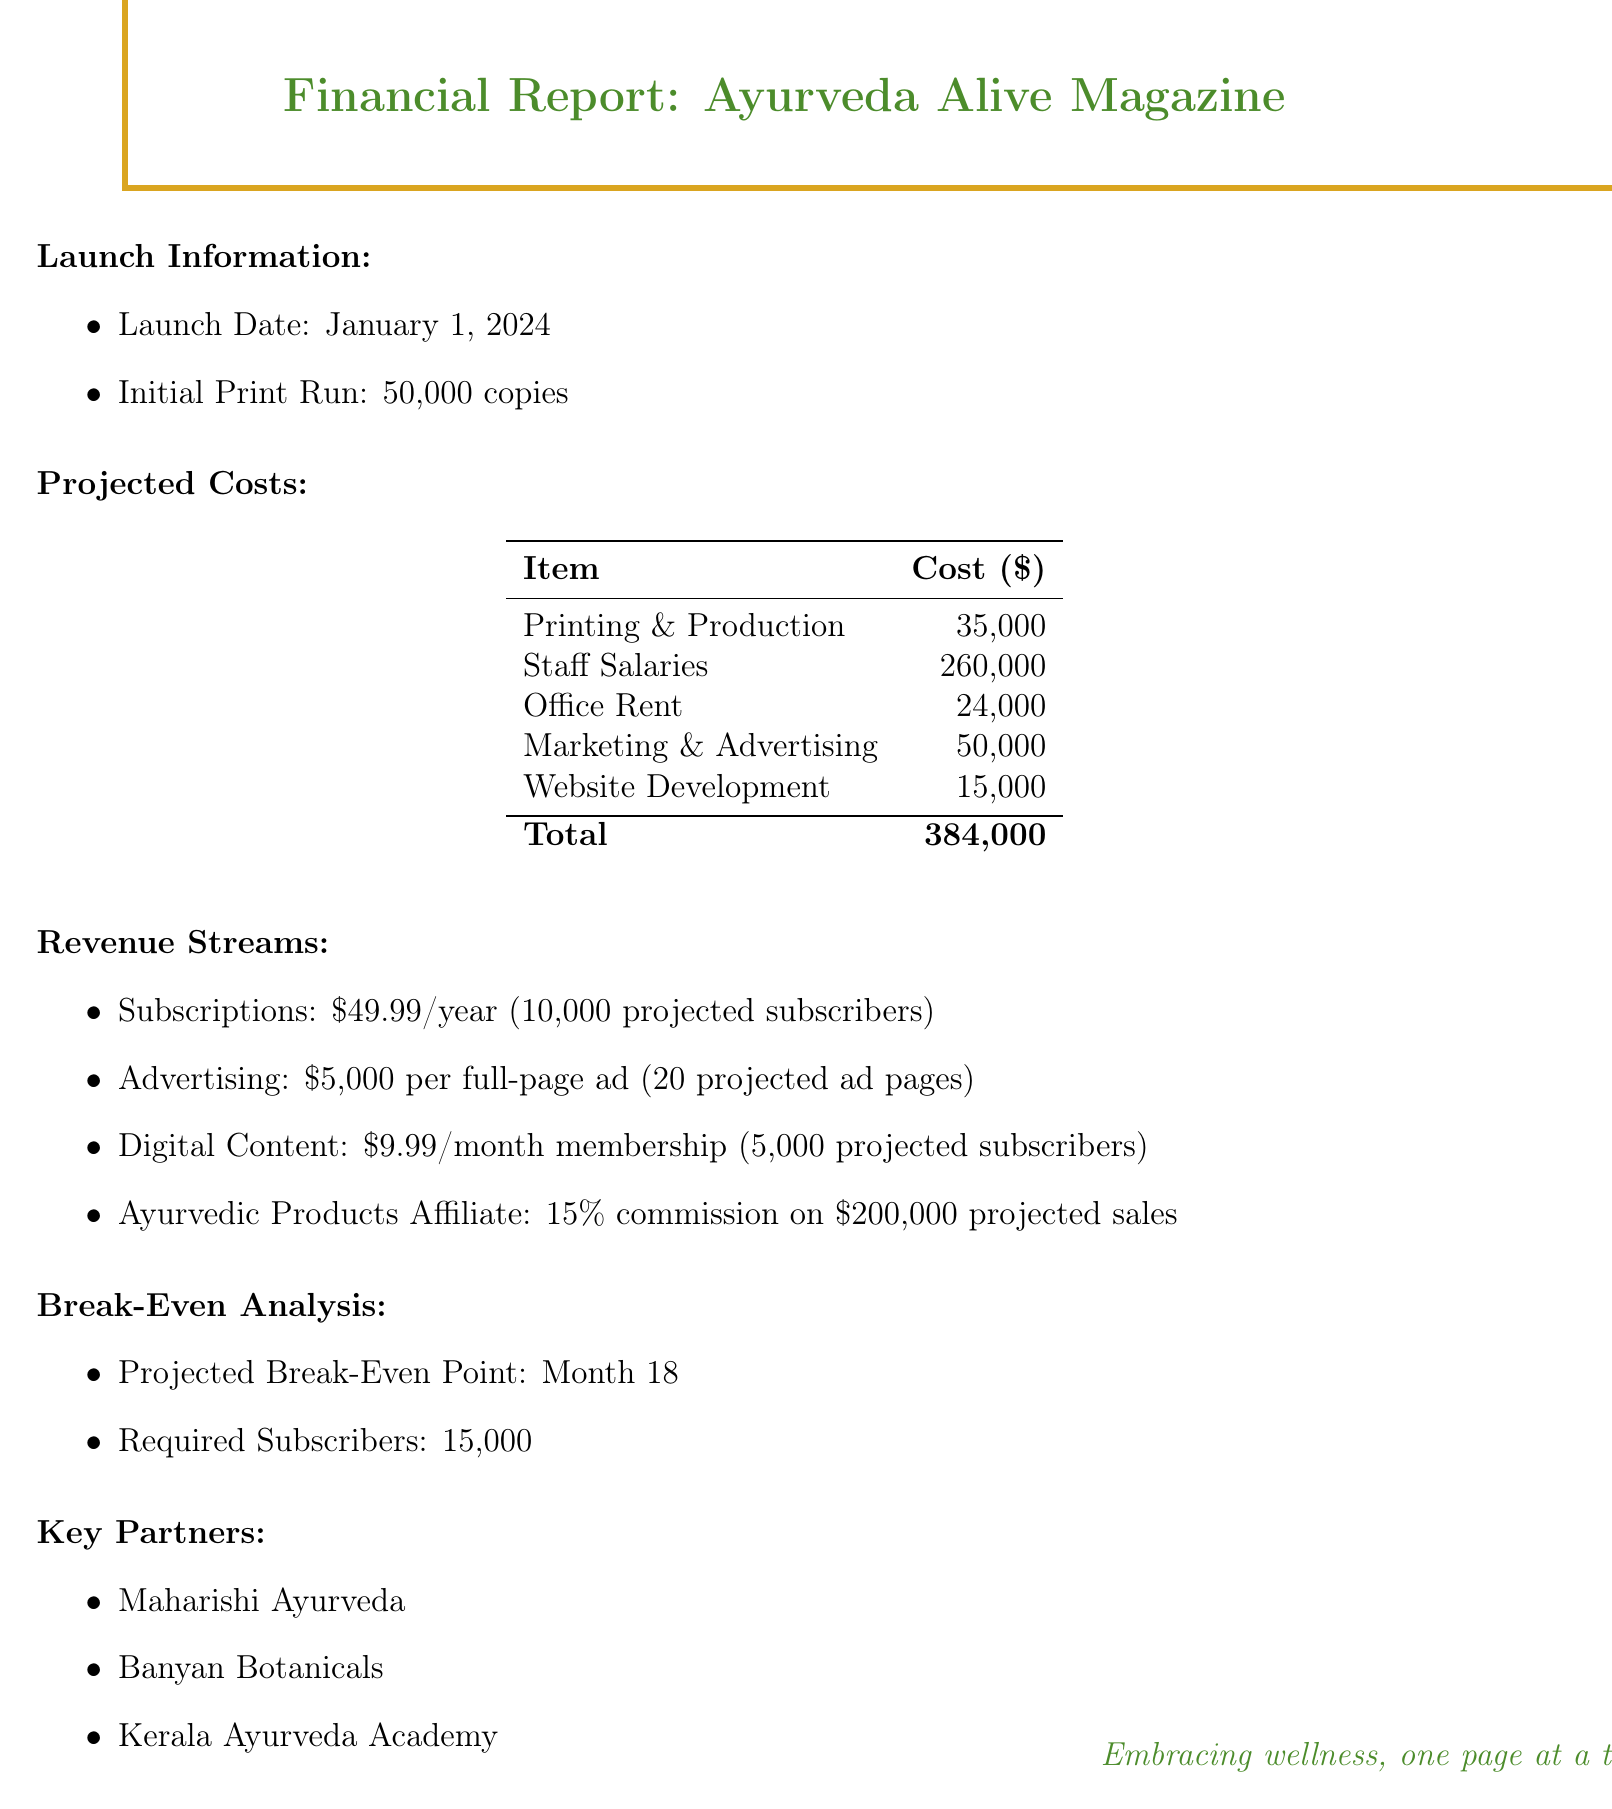what is the launch date of the magazine? The launch date is stated clearly in the document.
Answer: January 1, 2024 what is the initial print run for the magazine? The initial print run is mentioned as a specific number in the document.
Answer: 50000 what is the total projected cost of launching the magazine? The total projected cost is the sum of all individual costs listed in the document.
Answer: 384000 how many projected subscribers are needed to break even? The document specifies the number of subscribers required to reach the break-even point.
Answer: 15000 what is the annual subscription rate for the magazine? The subscription rate is detailed under the revenue streams in the document.
Answer: 49.99 how much revenue is projected from advertising? The document provides the projected income from advertising based on the number of ads and their rate.
Answer: 100000 what is the commission rate for Ayurvedic products affiliate? The document lists the commission rate under affiliate earnings as a percentage.
Answer: 15 percent which company is listed as a key partner? The document identifies several key partners in the wellness sector.
Answer: Maharishi Ayurveda how many projected digital subscribers are there? The document indicates the number of expected subscribers for digital content.
Answer: 5000 when is the projected break-even point? The document specifies the timeline for when the magazine is expected to break even financially.
Answer: Month 18 